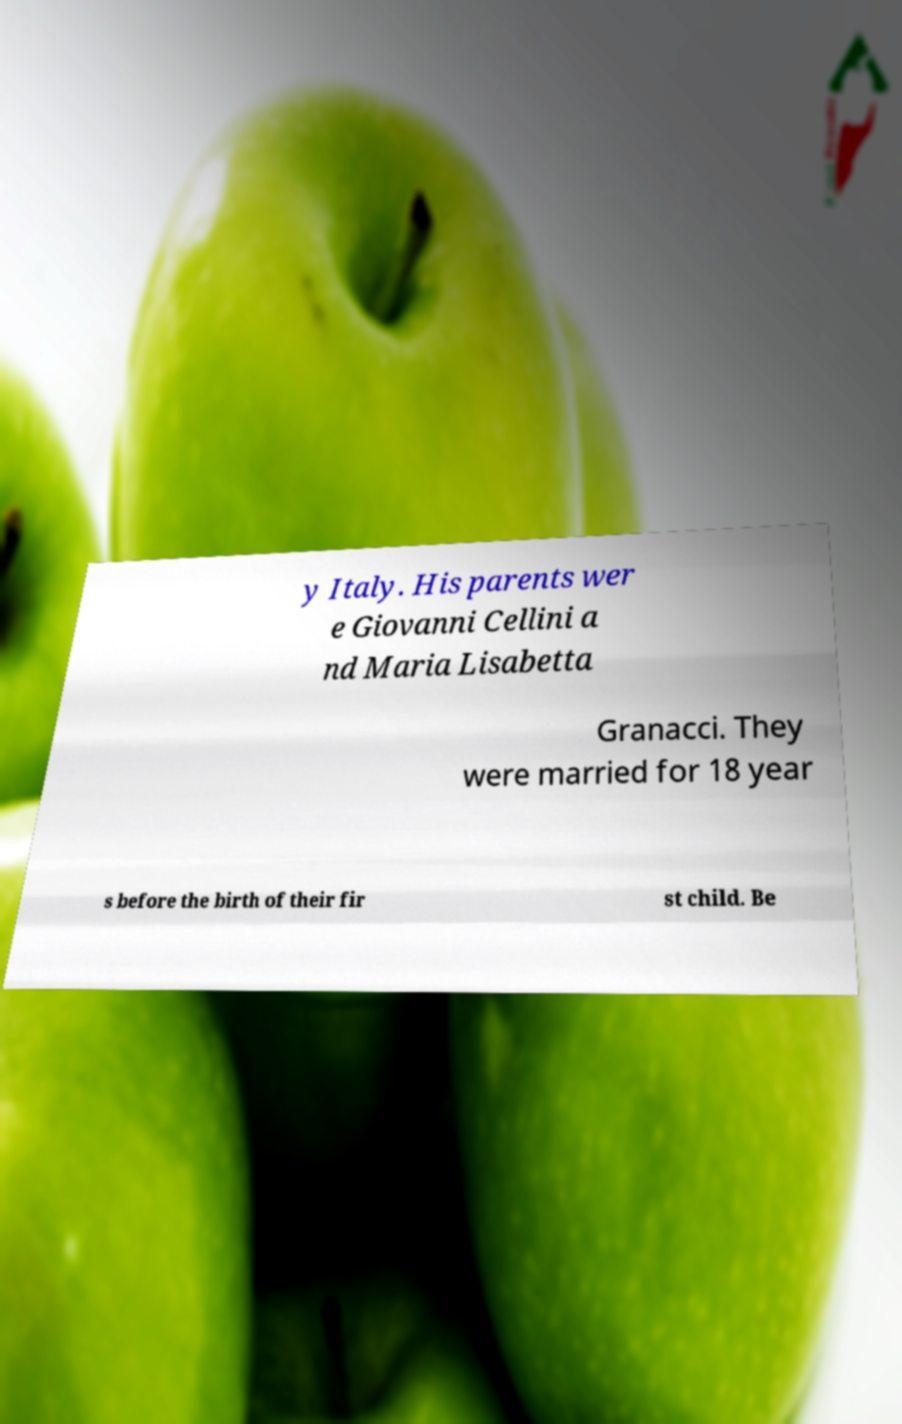There's text embedded in this image that I need extracted. Can you transcribe it verbatim? y Italy. His parents wer e Giovanni Cellini a nd Maria Lisabetta Granacci. They were married for 18 year s before the birth of their fir st child. Be 